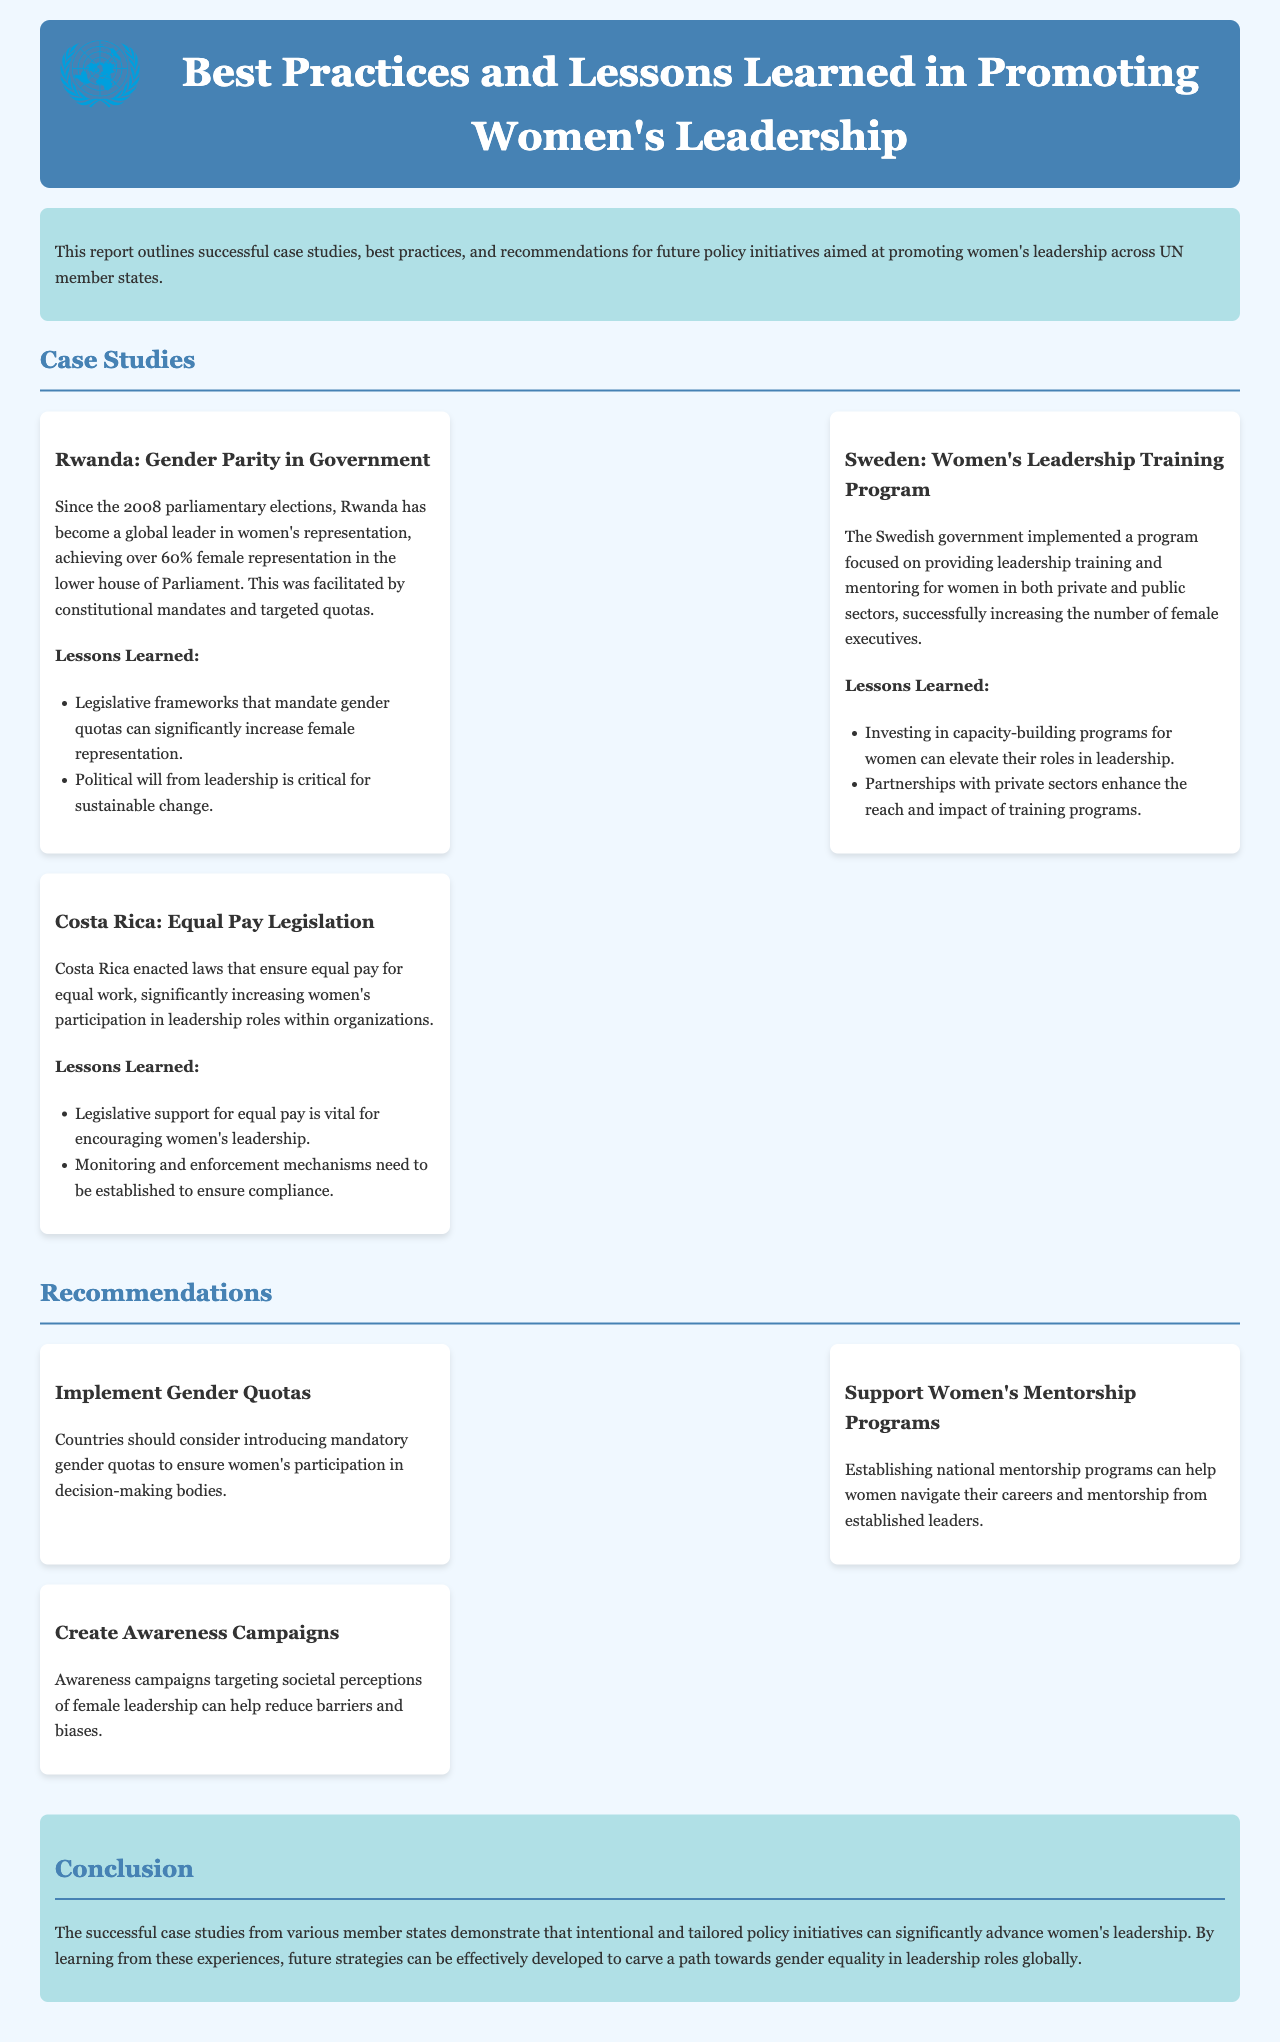What country achieved over 60% female representation in Parliament? This detail is found in the case study about Rwanda, highlighting its success since the 2008 elections.
Answer: Rwanda What program did Sweden implement to increase female executives? The case study mentions a program focused on leadership training and mentoring for women in both private and public sectors.
Answer: Women's Leadership Training Program What legislation did Costa Rica enact to promote women's leadership? The document specifies that Costa Rica enacted laws ensuring equal pay for equal work to support women's leadership participation.
Answer: Equal Pay Legislation How many successful case studies are detailed in the report? The report lists three distinct case studies of successful practices in promoting women's leadership.
Answer: Three What is one recommendation for increasing women's participation in decision-making? The recommendations section suggests implementing gender quotas as a means to boost women's representation in decision-making bodies.
Answer: Implement Gender Quotas What is a lesson learned from Rwanda's case study? The report notes the critical role of legislative frameworks and political will in promoting gender parity in leadership.
Answer: Political will from leadership is critical for sustainable change What should countries establish to help women navigate their careers, according to the recommendations? The report advocates for establishing national mentorship programs to assist women in their professional journeys.
Answer: Women's Mentorship Programs What overarching theme is highlighted in the report's conclusion? The conclusion underscores that intentional and tailored policy initiatives can significantly advance women's leadership globally.
Answer: Gender equality in leadership roles globally 